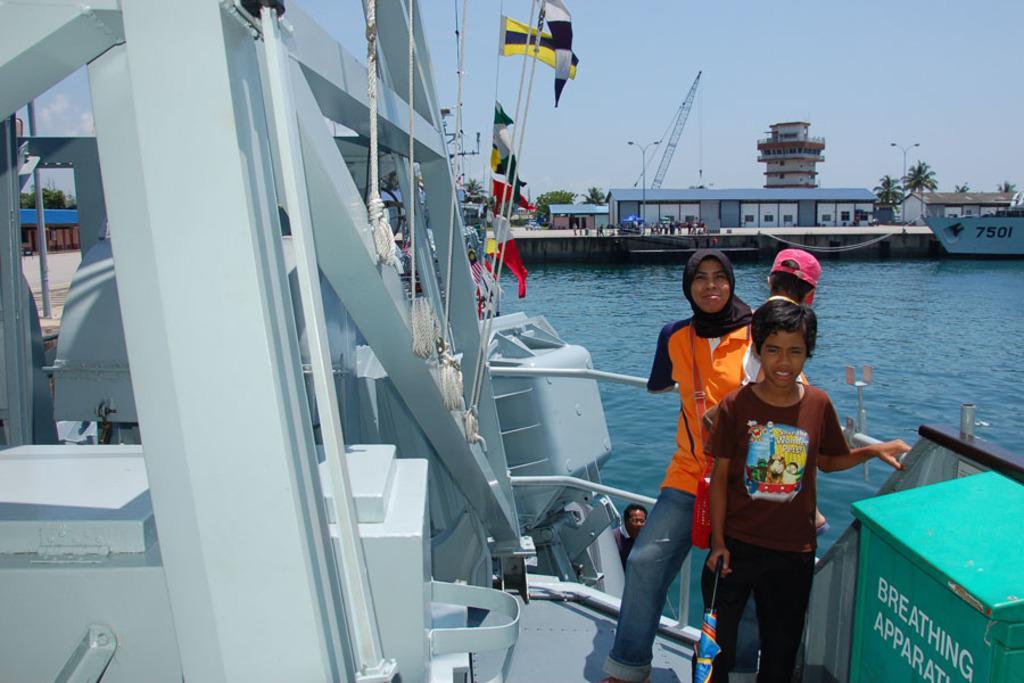Could you give a brief overview of what you see in this image? In this picture there is a girl who is wearing black scarf, t-shirt and jeans. Beside her there are two boys standing near to the fencing. On the back there's a man who is looking from the window. On the top we can see your many flags which are attached to this rope. On the right we can see a boat which is near to the land. On the right background we can see crane, shed, building, street light, trees, tower and peoples. On the top there is a sky. On the bottom right corner we can see green color box. 